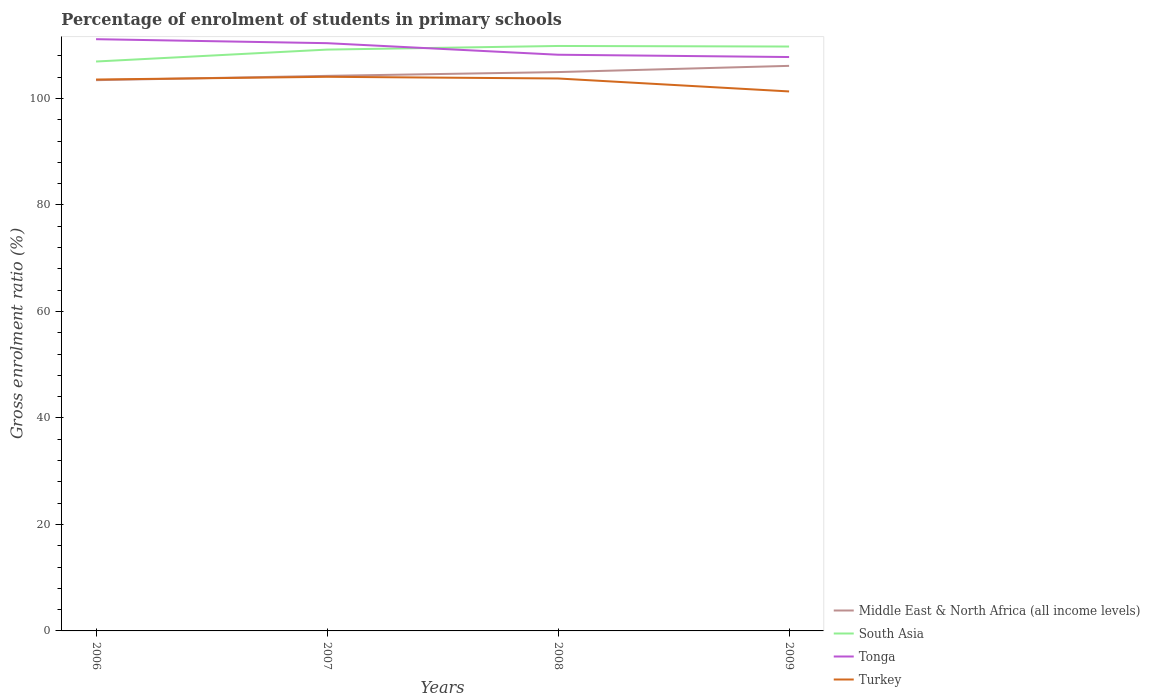How many different coloured lines are there?
Keep it short and to the point. 4. Across all years, what is the maximum percentage of students enrolled in primary schools in Tonga?
Keep it short and to the point. 107.78. What is the total percentage of students enrolled in primary schools in South Asia in the graph?
Make the answer very short. -0.57. What is the difference between the highest and the second highest percentage of students enrolled in primary schools in Middle East & North Africa (all income levels)?
Your answer should be very brief. 2.69. How many lines are there?
Give a very brief answer. 4. What is the difference between two consecutive major ticks on the Y-axis?
Make the answer very short. 20. Does the graph contain any zero values?
Provide a succinct answer. No. Where does the legend appear in the graph?
Provide a short and direct response. Bottom right. How many legend labels are there?
Your answer should be compact. 4. What is the title of the graph?
Your response must be concise. Percentage of enrolment of students in primary schools. Does "Chad" appear as one of the legend labels in the graph?
Keep it short and to the point. No. What is the label or title of the X-axis?
Your response must be concise. Years. What is the Gross enrolment ratio (%) of Middle East & North Africa (all income levels) in 2006?
Keep it short and to the point. 103.44. What is the Gross enrolment ratio (%) in South Asia in 2006?
Make the answer very short. 106.94. What is the Gross enrolment ratio (%) in Tonga in 2006?
Make the answer very short. 111.13. What is the Gross enrolment ratio (%) of Turkey in 2006?
Make the answer very short. 103.55. What is the Gross enrolment ratio (%) of Middle East & North Africa (all income levels) in 2007?
Give a very brief answer. 104.24. What is the Gross enrolment ratio (%) in South Asia in 2007?
Your response must be concise. 109.18. What is the Gross enrolment ratio (%) of Tonga in 2007?
Your answer should be very brief. 110.38. What is the Gross enrolment ratio (%) in Turkey in 2007?
Provide a short and direct response. 104.07. What is the Gross enrolment ratio (%) in Middle East & North Africa (all income levels) in 2008?
Ensure brevity in your answer.  104.96. What is the Gross enrolment ratio (%) of South Asia in 2008?
Ensure brevity in your answer.  109.86. What is the Gross enrolment ratio (%) in Tonga in 2008?
Give a very brief answer. 108.21. What is the Gross enrolment ratio (%) in Turkey in 2008?
Offer a very short reply. 103.75. What is the Gross enrolment ratio (%) of Middle East & North Africa (all income levels) in 2009?
Keep it short and to the point. 106.12. What is the Gross enrolment ratio (%) in South Asia in 2009?
Your answer should be very brief. 109.75. What is the Gross enrolment ratio (%) of Tonga in 2009?
Give a very brief answer. 107.78. What is the Gross enrolment ratio (%) in Turkey in 2009?
Your answer should be very brief. 101.32. Across all years, what is the maximum Gross enrolment ratio (%) in Middle East & North Africa (all income levels)?
Your answer should be compact. 106.12. Across all years, what is the maximum Gross enrolment ratio (%) of South Asia?
Provide a short and direct response. 109.86. Across all years, what is the maximum Gross enrolment ratio (%) in Tonga?
Provide a short and direct response. 111.13. Across all years, what is the maximum Gross enrolment ratio (%) in Turkey?
Provide a short and direct response. 104.07. Across all years, what is the minimum Gross enrolment ratio (%) of Middle East & North Africa (all income levels)?
Offer a terse response. 103.44. Across all years, what is the minimum Gross enrolment ratio (%) in South Asia?
Your response must be concise. 106.94. Across all years, what is the minimum Gross enrolment ratio (%) of Tonga?
Provide a short and direct response. 107.78. Across all years, what is the minimum Gross enrolment ratio (%) of Turkey?
Make the answer very short. 101.32. What is the total Gross enrolment ratio (%) in Middle East & North Africa (all income levels) in the graph?
Provide a short and direct response. 418.76. What is the total Gross enrolment ratio (%) in South Asia in the graph?
Make the answer very short. 435.73. What is the total Gross enrolment ratio (%) of Tonga in the graph?
Offer a very short reply. 437.51. What is the total Gross enrolment ratio (%) in Turkey in the graph?
Your answer should be very brief. 412.69. What is the difference between the Gross enrolment ratio (%) in Middle East & North Africa (all income levels) in 2006 and that in 2007?
Offer a terse response. -0.81. What is the difference between the Gross enrolment ratio (%) of South Asia in 2006 and that in 2007?
Provide a short and direct response. -2.24. What is the difference between the Gross enrolment ratio (%) in Tonga in 2006 and that in 2007?
Your answer should be compact. 0.75. What is the difference between the Gross enrolment ratio (%) of Turkey in 2006 and that in 2007?
Your response must be concise. -0.51. What is the difference between the Gross enrolment ratio (%) in Middle East & North Africa (all income levels) in 2006 and that in 2008?
Offer a terse response. -1.52. What is the difference between the Gross enrolment ratio (%) in South Asia in 2006 and that in 2008?
Provide a succinct answer. -2.92. What is the difference between the Gross enrolment ratio (%) of Tonga in 2006 and that in 2008?
Provide a short and direct response. 2.92. What is the difference between the Gross enrolment ratio (%) in Turkey in 2006 and that in 2008?
Offer a very short reply. -0.2. What is the difference between the Gross enrolment ratio (%) in Middle East & North Africa (all income levels) in 2006 and that in 2009?
Provide a succinct answer. -2.69. What is the difference between the Gross enrolment ratio (%) in South Asia in 2006 and that in 2009?
Your answer should be very brief. -2.82. What is the difference between the Gross enrolment ratio (%) in Tonga in 2006 and that in 2009?
Ensure brevity in your answer.  3.35. What is the difference between the Gross enrolment ratio (%) of Turkey in 2006 and that in 2009?
Make the answer very short. 2.24. What is the difference between the Gross enrolment ratio (%) in Middle East & North Africa (all income levels) in 2007 and that in 2008?
Ensure brevity in your answer.  -0.71. What is the difference between the Gross enrolment ratio (%) of South Asia in 2007 and that in 2008?
Your response must be concise. -0.68. What is the difference between the Gross enrolment ratio (%) in Tonga in 2007 and that in 2008?
Provide a short and direct response. 2.17. What is the difference between the Gross enrolment ratio (%) in Turkey in 2007 and that in 2008?
Provide a short and direct response. 0.32. What is the difference between the Gross enrolment ratio (%) in Middle East & North Africa (all income levels) in 2007 and that in 2009?
Keep it short and to the point. -1.88. What is the difference between the Gross enrolment ratio (%) in South Asia in 2007 and that in 2009?
Offer a terse response. -0.57. What is the difference between the Gross enrolment ratio (%) of Tonga in 2007 and that in 2009?
Provide a succinct answer. 2.6. What is the difference between the Gross enrolment ratio (%) in Turkey in 2007 and that in 2009?
Provide a short and direct response. 2.75. What is the difference between the Gross enrolment ratio (%) in Middle East & North Africa (all income levels) in 2008 and that in 2009?
Ensure brevity in your answer.  -1.17. What is the difference between the Gross enrolment ratio (%) in South Asia in 2008 and that in 2009?
Ensure brevity in your answer.  0.1. What is the difference between the Gross enrolment ratio (%) in Tonga in 2008 and that in 2009?
Offer a very short reply. 0.43. What is the difference between the Gross enrolment ratio (%) in Turkey in 2008 and that in 2009?
Provide a succinct answer. 2.43. What is the difference between the Gross enrolment ratio (%) in Middle East & North Africa (all income levels) in 2006 and the Gross enrolment ratio (%) in South Asia in 2007?
Your response must be concise. -5.74. What is the difference between the Gross enrolment ratio (%) in Middle East & North Africa (all income levels) in 2006 and the Gross enrolment ratio (%) in Tonga in 2007?
Keep it short and to the point. -6.95. What is the difference between the Gross enrolment ratio (%) of Middle East & North Africa (all income levels) in 2006 and the Gross enrolment ratio (%) of Turkey in 2007?
Your response must be concise. -0.63. What is the difference between the Gross enrolment ratio (%) in South Asia in 2006 and the Gross enrolment ratio (%) in Tonga in 2007?
Give a very brief answer. -3.45. What is the difference between the Gross enrolment ratio (%) of South Asia in 2006 and the Gross enrolment ratio (%) of Turkey in 2007?
Your response must be concise. 2.87. What is the difference between the Gross enrolment ratio (%) of Tonga in 2006 and the Gross enrolment ratio (%) of Turkey in 2007?
Your response must be concise. 7.06. What is the difference between the Gross enrolment ratio (%) of Middle East & North Africa (all income levels) in 2006 and the Gross enrolment ratio (%) of South Asia in 2008?
Ensure brevity in your answer.  -6.42. What is the difference between the Gross enrolment ratio (%) in Middle East & North Africa (all income levels) in 2006 and the Gross enrolment ratio (%) in Tonga in 2008?
Offer a terse response. -4.78. What is the difference between the Gross enrolment ratio (%) in Middle East & North Africa (all income levels) in 2006 and the Gross enrolment ratio (%) in Turkey in 2008?
Offer a terse response. -0.32. What is the difference between the Gross enrolment ratio (%) of South Asia in 2006 and the Gross enrolment ratio (%) of Tonga in 2008?
Provide a short and direct response. -1.28. What is the difference between the Gross enrolment ratio (%) in South Asia in 2006 and the Gross enrolment ratio (%) in Turkey in 2008?
Offer a terse response. 3.19. What is the difference between the Gross enrolment ratio (%) in Tonga in 2006 and the Gross enrolment ratio (%) in Turkey in 2008?
Provide a succinct answer. 7.38. What is the difference between the Gross enrolment ratio (%) of Middle East & North Africa (all income levels) in 2006 and the Gross enrolment ratio (%) of South Asia in 2009?
Provide a succinct answer. -6.32. What is the difference between the Gross enrolment ratio (%) of Middle East & North Africa (all income levels) in 2006 and the Gross enrolment ratio (%) of Tonga in 2009?
Your answer should be very brief. -4.35. What is the difference between the Gross enrolment ratio (%) in Middle East & North Africa (all income levels) in 2006 and the Gross enrolment ratio (%) in Turkey in 2009?
Keep it short and to the point. 2.12. What is the difference between the Gross enrolment ratio (%) of South Asia in 2006 and the Gross enrolment ratio (%) of Tonga in 2009?
Provide a succinct answer. -0.84. What is the difference between the Gross enrolment ratio (%) of South Asia in 2006 and the Gross enrolment ratio (%) of Turkey in 2009?
Ensure brevity in your answer.  5.62. What is the difference between the Gross enrolment ratio (%) in Tonga in 2006 and the Gross enrolment ratio (%) in Turkey in 2009?
Make the answer very short. 9.81. What is the difference between the Gross enrolment ratio (%) of Middle East & North Africa (all income levels) in 2007 and the Gross enrolment ratio (%) of South Asia in 2008?
Offer a very short reply. -5.61. What is the difference between the Gross enrolment ratio (%) in Middle East & North Africa (all income levels) in 2007 and the Gross enrolment ratio (%) in Tonga in 2008?
Provide a short and direct response. -3.97. What is the difference between the Gross enrolment ratio (%) of Middle East & North Africa (all income levels) in 2007 and the Gross enrolment ratio (%) of Turkey in 2008?
Make the answer very short. 0.49. What is the difference between the Gross enrolment ratio (%) in South Asia in 2007 and the Gross enrolment ratio (%) in Tonga in 2008?
Offer a terse response. 0.97. What is the difference between the Gross enrolment ratio (%) of South Asia in 2007 and the Gross enrolment ratio (%) of Turkey in 2008?
Offer a terse response. 5.43. What is the difference between the Gross enrolment ratio (%) of Tonga in 2007 and the Gross enrolment ratio (%) of Turkey in 2008?
Make the answer very short. 6.63. What is the difference between the Gross enrolment ratio (%) in Middle East & North Africa (all income levels) in 2007 and the Gross enrolment ratio (%) in South Asia in 2009?
Provide a succinct answer. -5.51. What is the difference between the Gross enrolment ratio (%) of Middle East & North Africa (all income levels) in 2007 and the Gross enrolment ratio (%) of Tonga in 2009?
Offer a very short reply. -3.54. What is the difference between the Gross enrolment ratio (%) of Middle East & North Africa (all income levels) in 2007 and the Gross enrolment ratio (%) of Turkey in 2009?
Your response must be concise. 2.92. What is the difference between the Gross enrolment ratio (%) in South Asia in 2007 and the Gross enrolment ratio (%) in Tonga in 2009?
Your answer should be very brief. 1.4. What is the difference between the Gross enrolment ratio (%) of South Asia in 2007 and the Gross enrolment ratio (%) of Turkey in 2009?
Ensure brevity in your answer.  7.86. What is the difference between the Gross enrolment ratio (%) in Tonga in 2007 and the Gross enrolment ratio (%) in Turkey in 2009?
Offer a terse response. 9.06. What is the difference between the Gross enrolment ratio (%) of Middle East & North Africa (all income levels) in 2008 and the Gross enrolment ratio (%) of South Asia in 2009?
Give a very brief answer. -4.8. What is the difference between the Gross enrolment ratio (%) in Middle East & North Africa (all income levels) in 2008 and the Gross enrolment ratio (%) in Tonga in 2009?
Offer a terse response. -2.83. What is the difference between the Gross enrolment ratio (%) in Middle East & North Africa (all income levels) in 2008 and the Gross enrolment ratio (%) in Turkey in 2009?
Your answer should be very brief. 3.64. What is the difference between the Gross enrolment ratio (%) in South Asia in 2008 and the Gross enrolment ratio (%) in Tonga in 2009?
Provide a short and direct response. 2.08. What is the difference between the Gross enrolment ratio (%) in South Asia in 2008 and the Gross enrolment ratio (%) in Turkey in 2009?
Offer a terse response. 8.54. What is the difference between the Gross enrolment ratio (%) in Tonga in 2008 and the Gross enrolment ratio (%) in Turkey in 2009?
Provide a short and direct response. 6.89. What is the average Gross enrolment ratio (%) of Middle East & North Africa (all income levels) per year?
Offer a terse response. 104.69. What is the average Gross enrolment ratio (%) in South Asia per year?
Offer a terse response. 108.93. What is the average Gross enrolment ratio (%) in Tonga per year?
Make the answer very short. 109.38. What is the average Gross enrolment ratio (%) in Turkey per year?
Offer a terse response. 103.17. In the year 2006, what is the difference between the Gross enrolment ratio (%) in Middle East & North Africa (all income levels) and Gross enrolment ratio (%) in South Asia?
Offer a terse response. -3.5. In the year 2006, what is the difference between the Gross enrolment ratio (%) in Middle East & North Africa (all income levels) and Gross enrolment ratio (%) in Tonga?
Your answer should be compact. -7.7. In the year 2006, what is the difference between the Gross enrolment ratio (%) in Middle East & North Africa (all income levels) and Gross enrolment ratio (%) in Turkey?
Offer a terse response. -0.12. In the year 2006, what is the difference between the Gross enrolment ratio (%) of South Asia and Gross enrolment ratio (%) of Tonga?
Your answer should be compact. -4.19. In the year 2006, what is the difference between the Gross enrolment ratio (%) in South Asia and Gross enrolment ratio (%) in Turkey?
Make the answer very short. 3.38. In the year 2006, what is the difference between the Gross enrolment ratio (%) of Tonga and Gross enrolment ratio (%) of Turkey?
Your answer should be compact. 7.58. In the year 2007, what is the difference between the Gross enrolment ratio (%) of Middle East & North Africa (all income levels) and Gross enrolment ratio (%) of South Asia?
Give a very brief answer. -4.94. In the year 2007, what is the difference between the Gross enrolment ratio (%) in Middle East & North Africa (all income levels) and Gross enrolment ratio (%) in Tonga?
Offer a very short reply. -6.14. In the year 2007, what is the difference between the Gross enrolment ratio (%) of Middle East & North Africa (all income levels) and Gross enrolment ratio (%) of Turkey?
Your answer should be compact. 0.18. In the year 2007, what is the difference between the Gross enrolment ratio (%) in South Asia and Gross enrolment ratio (%) in Tonga?
Provide a succinct answer. -1.2. In the year 2007, what is the difference between the Gross enrolment ratio (%) in South Asia and Gross enrolment ratio (%) in Turkey?
Provide a short and direct response. 5.11. In the year 2007, what is the difference between the Gross enrolment ratio (%) in Tonga and Gross enrolment ratio (%) in Turkey?
Make the answer very short. 6.32. In the year 2008, what is the difference between the Gross enrolment ratio (%) in Middle East & North Africa (all income levels) and Gross enrolment ratio (%) in South Asia?
Your answer should be very brief. -4.9. In the year 2008, what is the difference between the Gross enrolment ratio (%) of Middle East & North Africa (all income levels) and Gross enrolment ratio (%) of Tonga?
Offer a terse response. -3.26. In the year 2008, what is the difference between the Gross enrolment ratio (%) in Middle East & North Africa (all income levels) and Gross enrolment ratio (%) in Turkey?
Give a very brief answer. 1.2. In the year 2008, what is the difference between the Gross enrolment ratio (%) of South Asia and Gross enrolment ratio (%) of Tonga?
Offer a very short reply. 1.64. In the year 2008, what is the difference between the Gross enrolment ratio (%) of South Asia and Gross enrolment ratio (%) of Turkey?
Keep it short and to the point. 6.11. In the year 2008, what is the difference between the Gross enrolment ratio (%) in Tonga and Gross enrolment ratio (%) in Turkey?
Give a very brief answer. 4.46. In the year 2009, what is the difference between the Gross enrolment ratio (%) of Middle East & North Africa (all income levels) and Gross enrolment ratio (%) of South Asia?
Offer a terse response. -3.63. In the year 2009, what is the difference between the Gross enrolment ratio (%) in Middle East & North Africa (all income levels) and Gross enrolment ratio (%) in Tonga?
Give a very brief answer. -1.66. In the year 2009, what is the difference between the Gross enrolment ratio (%) in Middle East & North Africa (all income levels) and Gross enrolment ratio (%) in Turkey?
Give a very brief answer. 4.8. In the year 2009, what is the difference between the Gross enrolment ratio (%) in South Asia and Gross enrolment ratio (%) in Tonga?
Provide a succinct answer. 1.97. In the year 2009, what is the difference between the Gross enrolment ratio (%) in South Asia and Gross enrolment ratio (%) in Turkey?
Ensure brevity in your answer.  8.43. In the year 2009, what is the difference between the Gross enrolment ratio (%) in Tonga and Gross enrolment ratio (%) in Turkey?
Give a very brief answer. 6.46. What is the ratio of the Gross enrolment ratio (%) of South Asia in 2006 to that in 2007?
Make the answer very short. 0.98. What is the ratio of the Gross enrolment ratio (%) in Tonga in 2006 to that in 2007?
Provide a succinct answer. 1.01. What is the ratio of the Gross enrolment ratio (%) of Turkey in 2006 to that in 2007?
Ensure brevity in your answer.  1. What is the ratio of the Gross enrolment ratio (%) in Middle East & North Africa (all income levels) in 2006 to that in 2008?
Your response must be concise. 0.99. What is the ratio of the Gross enrolment ratio (%) in South Asia in 2006 to that in 2008?
Keep it short and to the point. 0.97. What is the ratio of the Gross enrolment ratio (%) in Tonga in 2006 to that in 2008?
Your answer should be compact. 1.03. What is the ratio of the Gross enrolment ratio (%) in Middle East & North Africa (all income levels) in 2006 to that in 2009?
Offer a terse response. 0.97. What is the ratio of the Gross enrolment ratio (%) of South Asia in 2006 to that in 2009?
Ensure brevity in your answer.  0.97. What is the ratio of the Gross enrolment ratio (%) in Tonga in 2006 to that in 2009?
Provide a succinct answer. 1.03. What is the ratio of the Gross enrolment ratio (%) in Turkey in 2006 to that in 2009?
Your response must be concise. 1.02. What is the ratio of the Gross enrolment ratio (%) in Middle East & North Africa (all income levels) in 2007 to that in 2008?
Your response must be concise. 0.99. What is the ratio of the Gross enrolment ratio (%) in South Asia in 2007 to that in 2008?
Ensure brevity in your answer.  0.99. What is the ratio of the Gross enrolment ratio (%) in Tonga in 2007 to that in 2008?
Your answer should be very brief. 1.02. What is the ratio of the Gross enrolment ratio (%) of Turkey in 2007 to that in 2008?
Offer a terse response. 1. What is the ratio of the Gross enrolment ratio (%) of Middle East & North Africa (all income levels) in 2007 to that in 2009?
Keep it short and to the point. 0.98. What is the ratio of the Gross enrolment ratio (%) in South Asia in 2007 to that in 2009?
Make the answer very short. 0.99. What is the ratio of the Gross enrolment ratio (%) in Tonga in 2007 to that in 2009?
Offer a very short reply. 1.02. What is the ratio of the Gross enrolment ratio (%) in Turkey in 2007 to that in 2009?
Give a very brief answer. 1.03. What is the ratio of the Gross enrolment ratio (%) in Tonga in 2008 to that in 2009?
Give a very brief answer. 1. What is the difference between the highest and the second highest Gross enrolment ratio (%) in Middle East & North Africa (all income levels)?
Make the answer very short. 1.17. What is the difference between the highest and the second highest Gross enrolment ratio (%) of South Asia?
Provide a short and direct response. 0.1. What is the difference between the highest and the second highest Gross enrolment ratio (%) of Tonga?
Provide a succinct answer. 0.75. What is the difference between the highest and the second highest Gross enrolment ratio (%) of Turkey?
Make the answer very short. 0.32. What is the difference between the highest and the lowest Gross enrolment ratio (%) in Middle East & North Africa (all income levels)?
Your response must be concise. 2.69. What is the difference between the highest and the lowest Gross enrolment ratio (%) of South Asia?
Provide a short and direct response. 2.92. What is the difference between the highest and the lowest Gross enrolment ratio (%) of Tonga?
Provide a short and direct response. 3.35. What is the difference between the highest and the lowest Gross enrolment ratio (%) of Turkey?
Offer a very short reply. 2.75. 